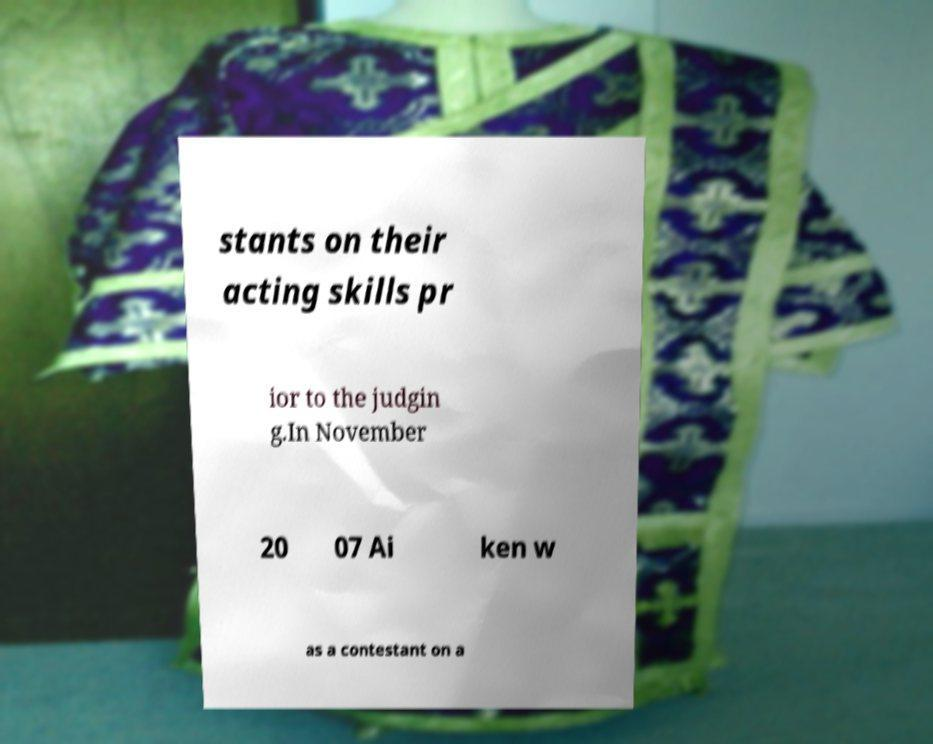Could you extract and type out the text from this image? stants on their acting skills pr ior to the judgin g.In November 20 07 Ai ken w as a contestant on a 